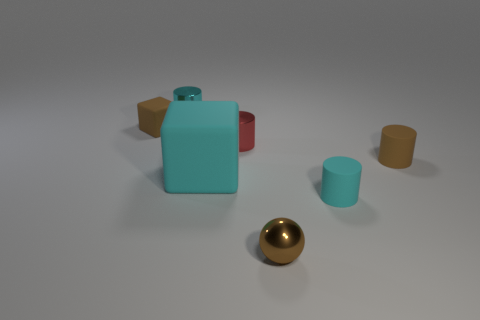What is the size of the metallic thing that is behind the tiny brown matte thing behind the metallic cylinder in front of the brown matte cube?
Give a very brief answer. Small. Are there more big blue rubber blocks than tiny blocks?
Give a very brief answer. No. There is a small rubber object left of the ball; does it have the same color as the sphere right of the brown block?
Keep it short and to the point. Yes. Is the brown object that is left of the large thing made of the same material as the block right of the small block?
Give a very brief answer. Yes. What number of cyan matte things have the same size as the red cylinder?
Your answer should be compact. 1. Are there fewer matte cubes than small cylinders?
Your response must be concise. Yes. There is a small brown rubber thing behind the small brown rubber thing on the right side of the brown sphere; what shape is it?
Offer a very short reply. Cube. What shape is the cyan matte thing that is the same size as the ball?
Offer a very short reply. Cylinder. Is there a brown object that has the same shape as the small cyan metallic object?
Your answer should be compact. Yes. What material is the tiny block?
Provide a short and direct response. Rubber. 